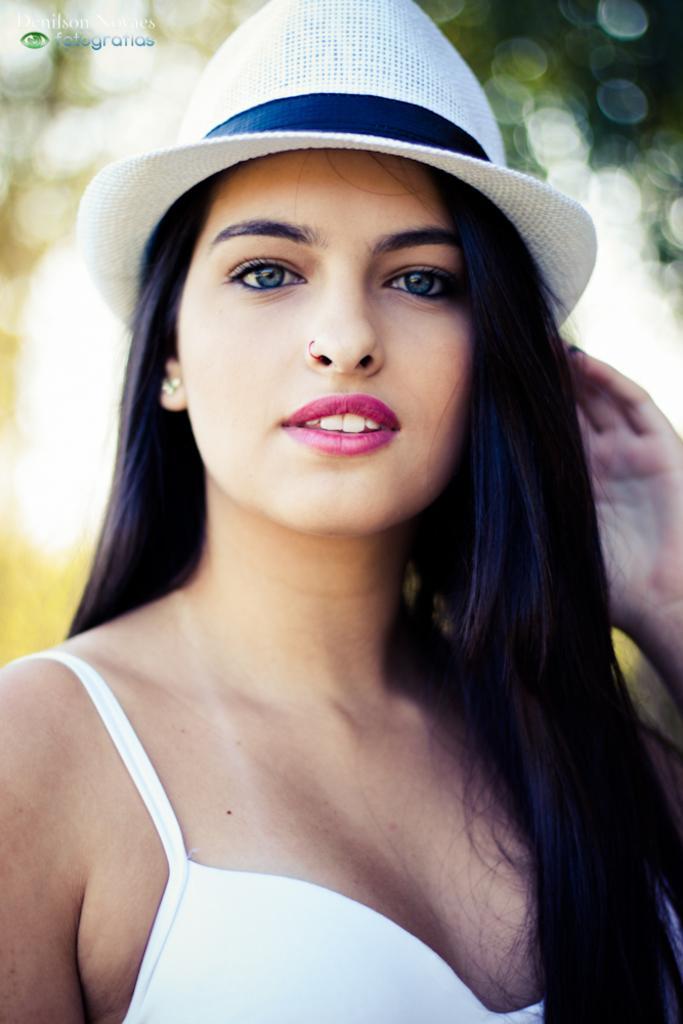Could you give a brief overview of what you see in this image? In the image we can see a woman standing, smiling and she wear a hat. Background of the image is blur. 